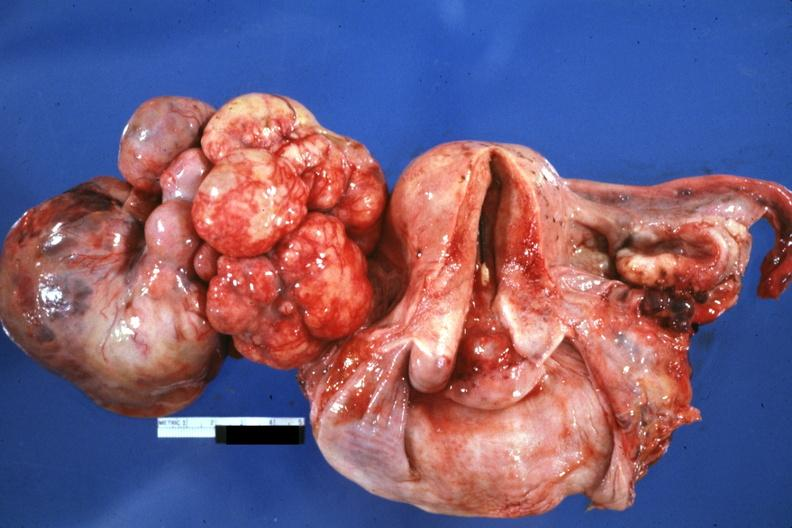what is present?
Answer the question using a single word or phrase. Ovary 